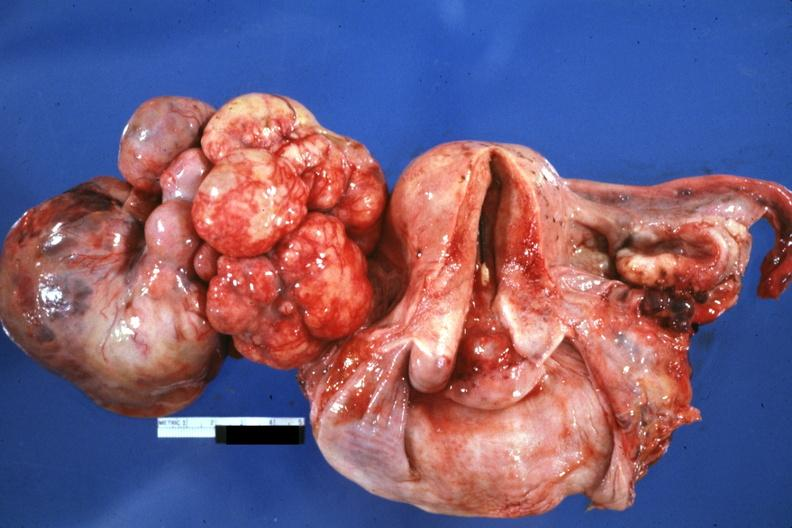what is present?
Answer the question using a single word or phrase. Ovary 